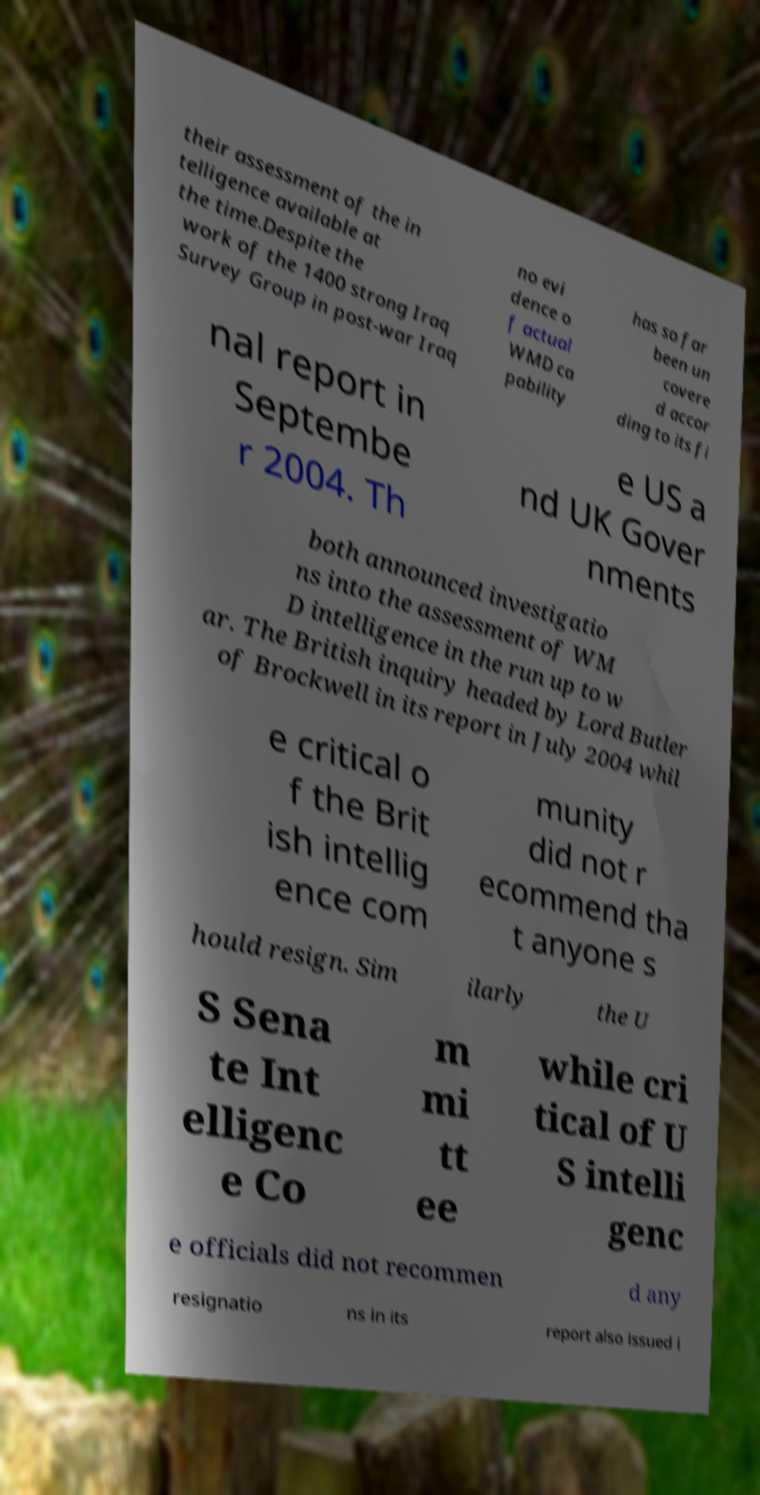For documentation purposes, I need the text within this image transcribed. Could you provide that? their assessment of the in telligence available at the time.Despite the work of the 1400 strong Iraq Survey Group in post-war Iraq no evi dence o f actual WMD ca pability has so far been un covere d accor ding to its fi nal report in Septembe r 2004. Th e US a nd UK Gover nments both announced investigatio ns into the assessment of WM D intelligence in the run up to w ar. The British inquiry headed by Lord Butler of Brockwell in its report in July 2004 whil e critical o f the Brit ish intellig ence com munity did not r ecommend tha t anyone s hould resign. Sim ilarly the U S Sena te Int elligenc e Co m mi tt ee while cri tical of U S intelli genc e officials did not recommen d any resignatio ns in its report also issued i 